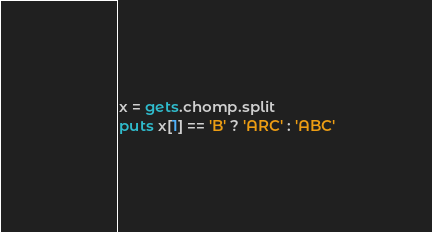Convert code to text. <code><loc_0><loc_0><loc_500><loc_500><_Ruby_>x = gets.chomp.split
puts x[1] == 'B' ? 'ARC' : 'ABC'</code> 